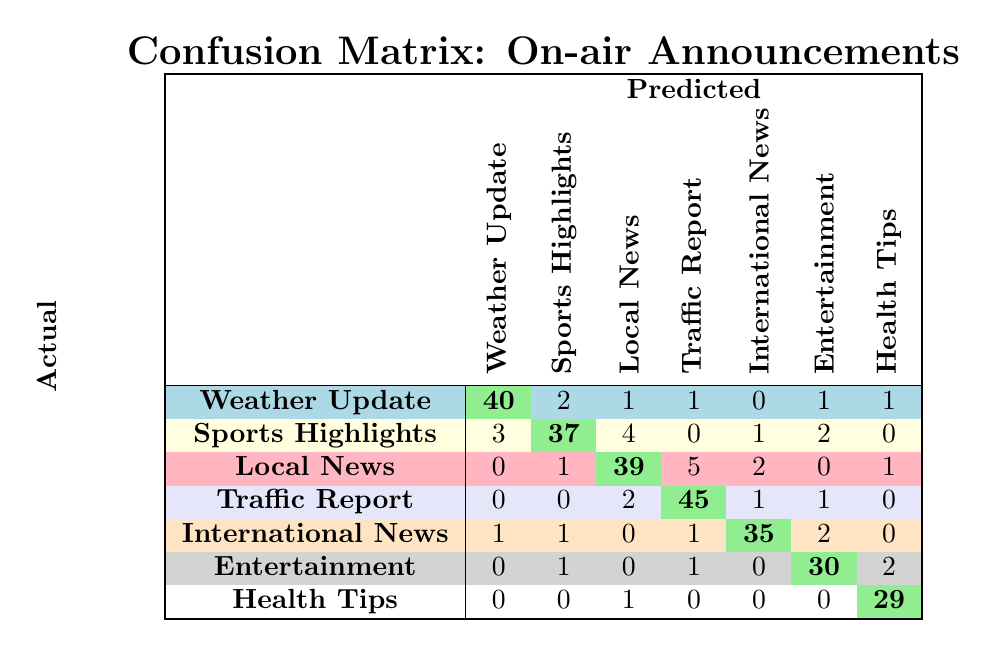What is the number of correctly predicted "Traffic Reports"? The value in the "Traffic Report" row and "Traffic Report" column gives the number of correct predictions for this category, which is 45.
Answer: 45 How many times was "Weather Update" incorrectly predicted as "Sports Highlights"? The value in the "Weather Update" row and "Sports Highlights" column indicates how many times "Weather Update" was incorrectly predicted, which is 2.
Answer: 2 What is the total number of "Entertainment" announcements? To find this, we sum all values in the "Entertainment" column: (0 + 1 + 0 + 1 + 0 + 30 + 2) = 34.
Answer: 34 Is the prediction accuracy for "Health Tips" higher than for "Local News"? For "Health Tips," the correct predictions are 29 and for "Local News," they are 39, so 29 is not greater than 39.
Answer: No What is the average number of correct predictions across all categories? The total number of correct predictions is (40 + 37 + 39 + 45 + 35 + 30 + 29) = 305. The number of categories is 7, so the average is 305/7 ≈ 43.57.
Answer: 43.57 How many correct predictions were made for "International News"? The value in the "International News" row and "International News" column gives the number of correct predictions, which is 35.
Answer: 35 What is the difference between correctly predicted "Local News" and "Health Tips"? The correct predictions for "Local News" are 39 and for "Health Tips" are 29. The difference is 39 - 29 = 10.
Answer: 10 How many total predictions were made for "Sports Highlights"? We sum all the values in the "Sports Highlights" column: (3 + 37 + 1 + 0 + 1 + 1 + 0) = 43.
Answer: 43 Which topic had the least number of correct predictions? By comparing the correct prediction values (40, 37, 39, 45, 35, 30, 29), "Health Tips" has the least correct predictions at 29.
Answer: Health Tips 